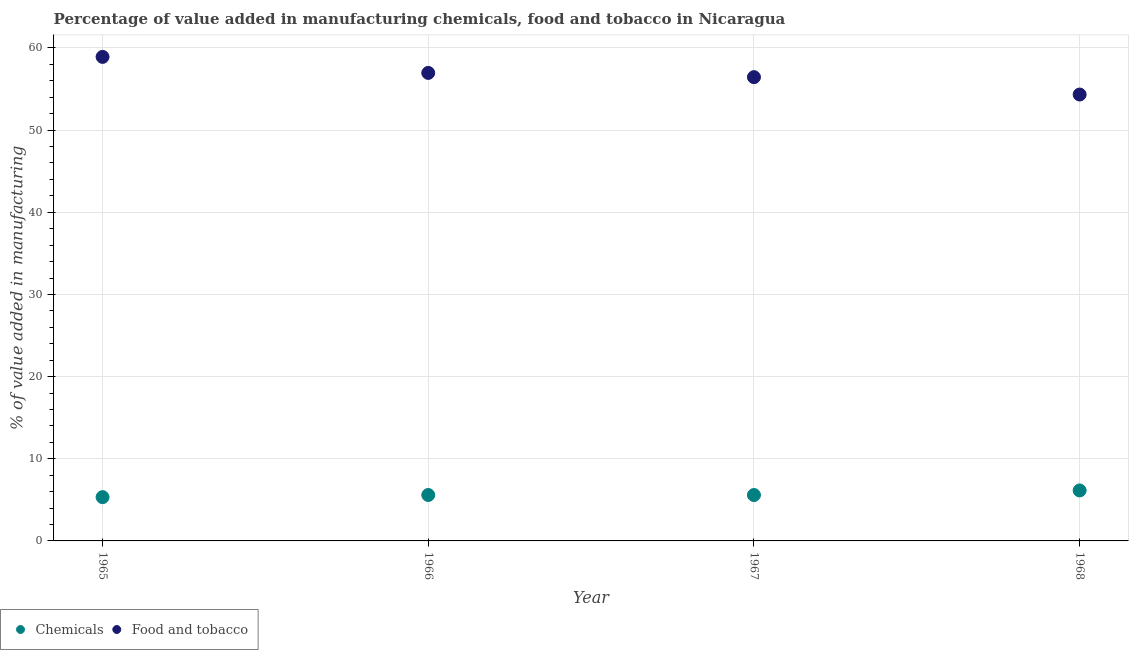How many different coloured dotlines are there?
Provide a short and direct response. 2. What is the value added by  manufacturing chemicals in 1965?
Offer a terse response. 5.33. Across all years, what is the maximum value added by  manufacturing chemicals?
Keep it short and to the point. 6.14. Across all years, what is the minimum value added by  manufacturing chemicals?
Keep it short and to the point. 5.33. In which year was the value added by  manufacturing chemicals maximum?
Give a very brief answer. 1968. In which year was the value added by manufacturing food and tobacco minimum?
Provide a succinct answer. 1968. What is the total value added by  manufacturing chemicals in the graph?
Your answer should be compact. 22.65. What is the difference between the value added by manufacturing food and tobacco in 1965 and that in 1967?
Your answer should be compact. 2.47. What is the difference between the value added by  manufacturing chemicals in 1966 and the value added by manufacturing food and tobacco in 1965?
Keep it short and to the point. -53.32. What is the average value added by manufacturing food and tobacco per year?
Your response must be concise. 56.66. In the year 1968, what is the difference between the value added by manufacturing food and tobacco and value added by  manufacturing chemicals?
Your answer should be compact. 48.19. In how many years, is the value added by  manufacturing chemicals greater than 52 %?
Your answer should be compact. 0. What is the ratio of the value added by  manufacturing chemicals in 1965 to that in 1968?
Your response must be concise. 0.87. Is the value added by manufacturing food and tobacco in 1965 less than that in 1968?
Your response must be concise. No. Is the difference between the value added by manufacturing food and tobacco in 1965 and 1967 greater than the difference between the value added by  manufacturing chemicals in 1965 and 1967?
Provide a succinct answer. Yes. What is the difference between the highest and the second highest value added by manufacturing food and tobacco?
Your response must be concise. 1.95. What is the difference between the highest and the lowest value added by  manufacturing chemicals?
Your answer should be compact. 0.82. In how many years, is the value added by  manufacturing chemicals greater than the average value added by  manufacturing chemicals taken over all years?
Keep it short and to the point. 1. Is the sum of the value added by  manufacturing chemicals in 1965 and 1967 greater than the maximum value added by manufacturing food and tobacco across all years?
Provide a succinct answer. No. Is the value added by manufacturing food and tobacco strictly greater than the value added by  manufacturing chemicals over the years?
Your answer should be compact. Yes. Is the value added by  manufacturing chemicals strictly less than the value added by manufacturing food and tobacco over the years?
Your answer should be very brief. Yes. What is the difference between two consecutive major ticks on the Y-axis?
Offer a very short reply. 10. Does the graph contain grids?
Ensure brevity in your answer.  Yes. Where does the legend appear in the graph?
Offer a terse response. Bottom left. How are the legend labels stacked?
Ensure brevity in your answer.  Horizontal. What is the title of the graph?
Provide a short and direct response. Percentage of value added in manufacturing chemicals, food and tobacco in Nicaragua. What is the label or title of the Y-axis?
Give a very brief answer. % of value added in manufacturing. What is the % of value added in manufacturing of Chemicals in 1965?
Give a very brief answer. 5.33. What is the % of value added in manufacturing of Food and tobacco in 1965?
Ensure brevity in your answer.  58.91. What is the % of value added in manufacturing in Chemicals in 1966?
Ensure brevity in your answer.  5.59. What is the % of value added in manufacturing in Food and tobacco in 1966?
Make the answer very short. 56.96. What is the % of value added in manufacturing in Chemicals in 1967?
Ensure brevity in your answer.  5.59. What is the % of value added in manufacturing of Food and tobacco in 1967?
Provide a short and direct response. 56.45. What is the % of value added in manufacturing of Chemicals in 1968?
Your answer should be compact. 6.14. What is the % of value added in manufacturing of Food and tobacco in 1968?
Offer a terse response. 54.33. Across all years, what is the maximum % of value added in manufacturing in Chemicals?
Your answer should be very brief. 6.14. Across all years, what is the maximum % of value added in manufacturing of Food and tobacco?
Provide a short and direct response. 58.91. Across all years, what is the minimum % of value added in manufacturing in Chemicals?
Ensure brevity in your answer.  5.33. Across all years, what is the minimum % of value added in manufacturing of Food and tobacco?
Your answer should be compact. 54.33. What is the total % of value added in manufacturing of Chemicals in the graph?
Provide a short and direct response. 22.65. What is the total % of value added in manufacturing in Food and tobacco in the graph?
Your answer should be very brief. 226.66. What is the difference between the % of value added in manufacturing in Chemicals in 1965 and that in 1966?
Provide a short and direct response. -0.26. What is the difference between the % of value added in manufacturing of Food and tobacco in 1965 and that in 1966?
Offer a very short reply. 1.95. What is the difference between the % of value added in manufacturing of Chemicals in 1965 and that in 1967?
Your answer should be very brief. -0.26. What is the difference between the % of value added in manufacturing of Food and tobacco in 1965 and that in 1967?
Provide a short and direct response. 2.47. What is the difference between the % of value added in manufacturing of Chemicals in 1965 and that in 1968?
Offer a terse response. -0.82. What is the difference between the % of value added in manufacturing in Food and tobacco in 1965 and that in 1968?
Ensure brevity in your answer.  4.58. What is the difference between the % of value added in manufacturing of Chemicals in 1966 and that in 1967?
Give a very brief answer. 0. What is the difference between the % of value added in manufacturing of Food and tobacco in 1966 and that in 1967?
Offer a very short reply. 0.52. What is the difference between the % of value added in manufacturing of Chemicals in 1966 and that in 1968?
Your response must be concise. -0.55. What is the difference between the % of value added in manufacturing of Food and tobacco in 1966 and that in 1968?
Your response must be concise. 2.63. What is the difference between the % of value added in manufacturing of Chemicals in 1967 and that in 1968?
Provide a succinct answer. -0.56. What is the difference between the % of value added in manufacturing of Food and tobacco in 1967 and that in 1968?
Give a very brief answer. 2.11. What is the difference between the % of value added in manufacturing of Chemicals in 1965 and the % of value added in manufacturing of Food and tobacco in 1966?
Keep it short and to the point. -51.63. What is the difference between the % of value added in manufacturing in Chemicals in 1965 and the % of value added in manufacturing in Food and tobacco in 1967?
Ensure brevity in your answer.  -51.12. What is the difference between the % of value added in manufacturing of Chemicals in 1965 and the % of value added in manufacturing of Food and tobacco in 1968?
Ensure brevity in your answer.  -49.01. What is the difference between the % of value added in manufacturing in Chemicals in 1966 and the % of value added in manufacturing in Food and tobacco in 1967?
Make the answer very short. -50.86. What is the difference between the % of value added in manufacturing in Chemicals in 1966 and the % of value added in manufacturing in Food and tobacco in 1968?
Provide a succinct answer. -48.74. What is the difference between the % of value added in manufacturing in Chemicals in 1967 and the % of value added in manufacturing in Food and tobacco in 1968?
Your answer should be compact. -48.75. What is the average % of value added in manufacturing of Chemicals per year?
Make the answer very short. 5.66. What is the average % of value added in manufacturing of Food and tobacco per year?
Offer a very short reply. 56.66. In the year 1965, what is the difference between the % of value added in manufacturing of Chemicals and % of value added in manufacturing of Food and tobacco?
Provide a short and direct response. -53.59. In the year 1966, what is the difference between the % of value added in manufacturing in Chemicals and % of value added in manufacturing in Food and tobacco?
Give a very brief answer. -51.37. In the year 1967, what is the difference between the % of value added in manufacturing of Chemicals and % of value added in manufacturing of Food and tobacco?
Provide a succinct answer. -50.86. In the year 1968, what is the difference between the % of value added in manufacturing of Chemicals and % of value added in manufacturing of Food and tobacco?
Provide a short and direct response. -48.19. What is the ratio of the % of value added in manufacturing of Chemicals in 1965 to that in 1966?
Offer a very short reply. 0.95. What is the ratio of the % of value added in manufacturing of Food and tobacco in 1965 to that in 1966?
Offer a terse response. 1.03. What is the ratio of the % of value added in manufacturing in Chemicals in 1965 to that in 1967?
Give a very brief answer. 0.95. What is the ratio of the % of value added in manufacturing of Food and tobacco in 1965 to that in 1967?
Offer a terse response. 1.04. What is the ratio of the % of value added in manufacturing of Chemicals in 1965 to that in 1968?
Provide a succinct answer. 0.87. What is the ratio of the % of value added in manufacturing of Food and tobacco in 1965 to that in 1968?
Keep it short and to the point. 1.08. What is the ratio of the % of value added in manufacturing of Chemicals in 1966 to that in 1967?
Make the answer very short. 1. What is the ratio of the % of value added in manufacturing of Food and tobacco in 1966 to that in 1967?
Your answer should be very brief. 1.01. What is the ratio of the % of value added in manufacturing of Chemicals in 1966 to that in 1968?
Your answer should be very brief. 0.91. What is the ratio of the % of value added in manufacturing of Food and tobacco in 1966 to that in 1968?
Provide a short and direct response. 1.05. What is the ratio of the % of value added in manufacturing in Chemicals in 1967 to that in 1968?
Provide a succinct answer. 0.91. What is the ratio of the % of value added in manufacturing in Food and tobacco in 1967 to that in 1968?
Keep it short and to the point. 1.04. What is the difference between the highest and the second highest % of value added in manufacturing in Chemicals?
Your answer should be compact. 0.55. What is the difference between the highest and the second highest % of value added in manufacturing of Food and tobacco?
Offer a terse response. 1.95. What is the difference between the highest and the lowest % of value added in manufacturing of Chemicals?
Make the answer very short. 0.82. What is the difference between the highest and the lowest % of value added in manufacturing of Food and tobacco?
Provide a short and direct response. 4.58. 